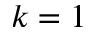<formula> <loc_0><loc_0><loc_500><loc_500>k = 1</formula> 